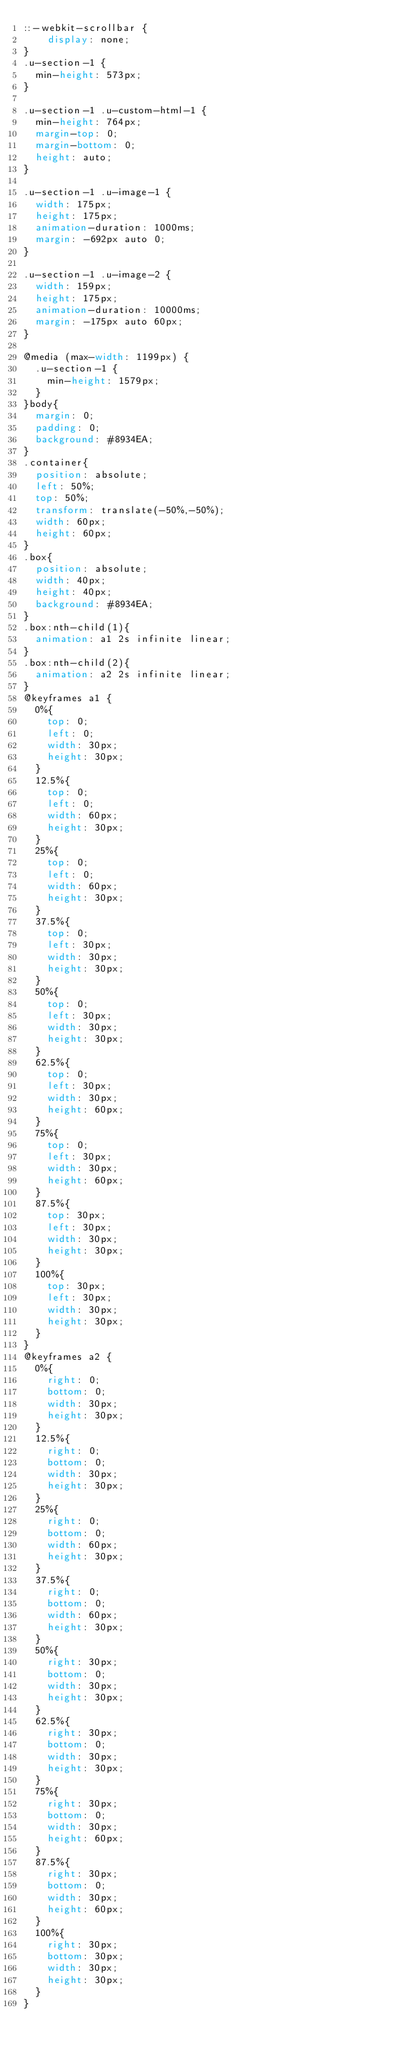<code> <loc_0><loc_0><loc_500><loc_500><_CSS_>::-webkit-scrollbar {
    display: none;
}
.u-section-1 {
  min-height: 573px;
}

.u-section-1 .u-custom-html-1 {
  min-height: 764px;
  margin-top: 0;
  margin-bottom: 0;
  height: auto;
}

.u-section-1 .u-image-1 {
  width: 175px;
  height: 175px;
  animation-duration: 1000ms;
  margin: -692px auto 0;
}

.u-section-1 .u-image-2 {
  width: 159px;
  height: 175px;
  animation-duration: 10000ms;
  margin: -175px auto 60px;
}

@media (max-width: 1199px) {
  .u-section-1 {
    min-height: 1579px;
  }
}body{
  margin: 0;
  padding: 0;
  background: #8934EA;
}
.container{
  position: absolute;
  left: 50%;
  top: 50%;
  transform: translate(-50%,-50%);
  width: 60px;
  height: 60px;
}
.box{
  position: absolute;
  width: 40px;
  height: 40px;
  background: #8934EA;
}
.box:nth-child(1){
  animation: a1 2s infinite linear;
}
.box:nth-child(2){
  animation: a2 2s infinite linear;
}
@keyframes a1 {
  0%{
    top: 0;
    left: 0;
    width: 30px;
    height: 30px;
  }
  12.5%{
    top: 0;
    left: 0;
    width: 60px;
    height: 30px;
  }
  25%{
    top: 0;
    left: 0;
    width: 60px;
    height: 30px;
  }
  37.5%{
    top: 0;
    left: 30px;
    width: 30px;
    height: 30px;
  }
  50%{
    top: 0;
    left: 30px;
    width: 30px;
    height: 30px;
  }
  62.5%{
    top: 0;
    left: 30px;
    width: 30px;
    height: 60px;
  }
  75%{
    top: 0;
    left: 30px;
    width: 30px;
    height: 60px;
  }
  87.5%{
    top: 30px;
    left: 30px;
    width: 30px;
    height: 30px;
  }
  100%{
    top: 30px;
    left: 30px;
    width: 30px;
    height: 30px;
  }
}
@keyframes a2 {
  0%{
    right: 0;
    bottom: 0;
    width: 30px;
    height: 30px;
  }
  12.5%{
    right: 0;
    bottom: 0;
    width: 30px;
    height: 30px;
  }
  25%{
    right: 0;
    bottom: 0;
    width: 60px;
    height: 30px;
  }
  37.5%{
    right: 0;
    bottom: 0;
    width: 60px;
    height: 30px;
  }
  50%{
    right: 30px;
    bottom: 0;
    width: 30px;
    height: 30px;
  }
  62.5%{
    right: 30px;
    bottom: 0;
    width: 30px;
    height: 30px;
  }
  75%{
    right: 30px;
    bottom: 0;
    width: 30px;
    height: 60px;
  }
  87.5%{
    right: 30px;
    bottom: 0;
    width: 30px;
    height: 60px;
  }
  100%{
    right: 30px;
    bottom: 30px;
    width: 30px;
    height: 30px;
  }
} </code> 